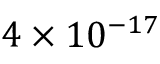<formula> <loc_0><loc_0><loc_500><loc_500>4 \times 1 0 ^ { - 1 7 }</formula> 